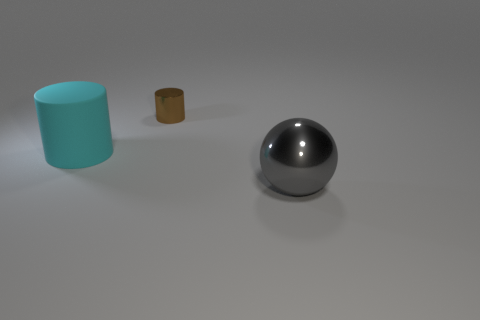What shape is the shiny thing behind the thing in front of the large cyan thing?
Your answer should be very brief. Cylinder. What number of other things are there of the same material as the tiny cylinder
Offer a terse response. 1. Is there any other thing that is the same size as the cyan matte cylinder?
Provide a succinct answer. Yes. Is the number of tiny cylinders greater than the number of large gray matte cubes?
Offer a terse response. Yes. What is the size of the shiny object in front of the cylinder behind the thing to the left of the small brown object?
Make the answer very short. Large. There is a cyan cylinder; does it have the same size as the shiny object behind the gray shiny object?
Your response must be concise. No. Is the number of large metallic balls that are in front of the gray sphere less than the number of large objects?
Offer a very short reply. Yes. What number of metal spheres are the same color as the matte cylinder?
Keep it short and to the point. 0. Is the number of large gray things less than the number of small blue rubber cylinders?
Your answer should be compact. No. Does the brown cylinder have the same material as the large sphere?
Your response must be concise. Yes. 